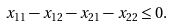Convert formula to latex. <formula><loc_0><loc_0><loc_500><loc_500>x _ { 1 1 } - x _ { 1 2 } - x _ { 2 1 } - x _ { 2 2 } \leq 0 .</formula> 